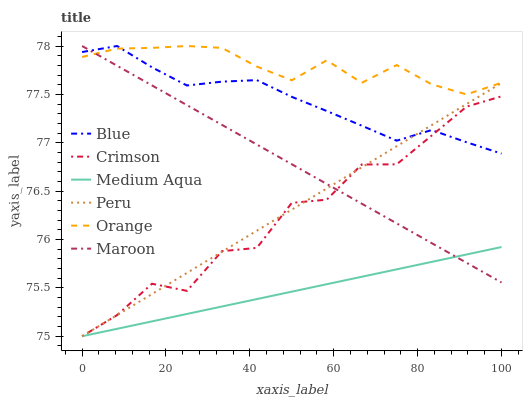Does Medium Aqua have the minimum area under the curve?
Answer yes or no. Yes. Does Orange have the maximum area under the curve?
Answer yes or no. Yes. Does Maroon have the minimum area under the curve?
Answer yes or no. No. Does Maroon have the maximum area under the curve?
Answer yes or no. No. Is Maroon the smoothest?
Answer yes or no. Yes. Is Crimson the roughest?
Answer yes or no. Yes. Is Orange the smoothest?
Answer yes or no. No. Is Orange the roughest?
Answer yes or no. No. Does Medium Aqua have the lowest value?
Answer yes or no. Yes. Does Maroon have the lowest value?
Answer yes or no. No. Does Orange have the highest value?
Answer yes or no. Yes. Does Medium Aqua have the highest value?
Answer yes or no. No. Is Medium Aqua less than Blue?
Answer yes or no. Yes. Is Orange greater than Crimson?
Answer yes or no. Yes. Does Blue intersect Orange?
Answer yes or no. Yes. Is Blue less than Orange?
Answer yes or no. No. Is Blue greater than Orange?
Answer yes or no. No. Does Medium Aqua intersect Blue?
Answer yes or no. No. 